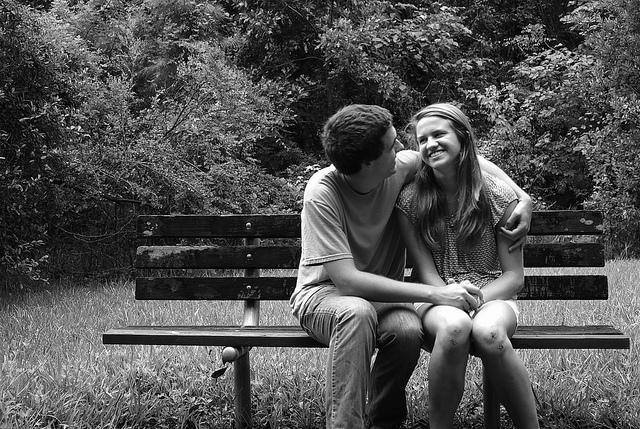How many colors appear in this image?
Give a very brief answer. 2. How many people are there?
Give a very brief answer. 2. 